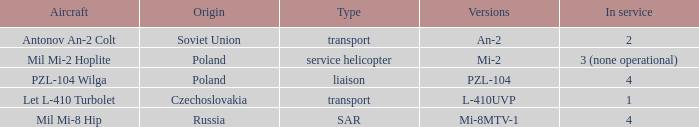Tell me the versions for czechoslovakia? L-410UVP. 